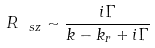<formula> <loc_0><loc_0><loc_500><loc_500>R _ { \ s z } \sim \frac { i \Gamma } { k - k _ { r } + i \Gamma }</formula> 